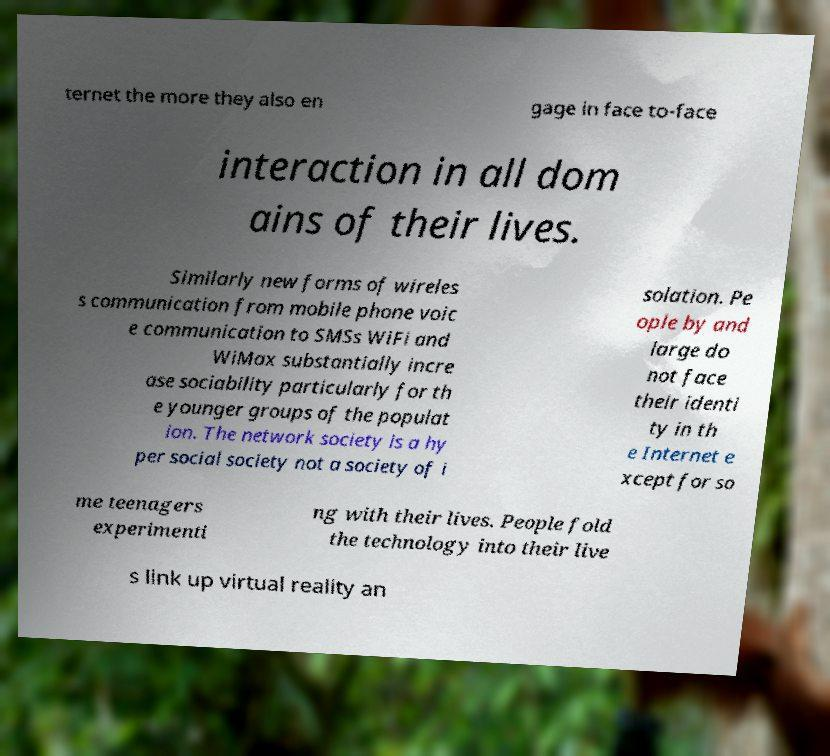Can you accurately transcribe the text from the provided image for me? ternet the more they also en gage in face to-face interaction in all dom ains of their lives. Similarly new forms of wireles s communication from mobile phone voic e communication to SMSs WiFi and WiMax substantially incre ase sociability particularly for th e younger groups of the populat ion. The network society is a hy per social society not a society of i solation. Pe ople by and large do not face their identi ty in th e Internet e xcept for so me teenagers experimenti ng with their lives. People fold the technology into their live s link up virtual reality an 